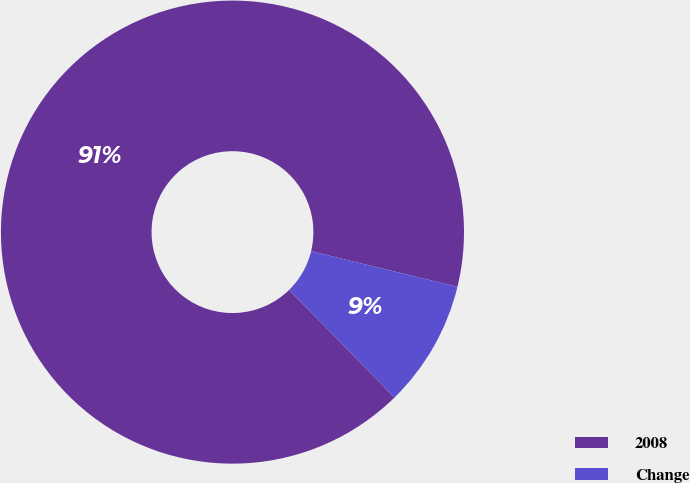<chart> <loc_0><loc_0><loc_500><loc_500><pie_chart><fcel>2008<fcel>Change<nl><fcel>91.13%<fcel>8.87%<nl></chart> 